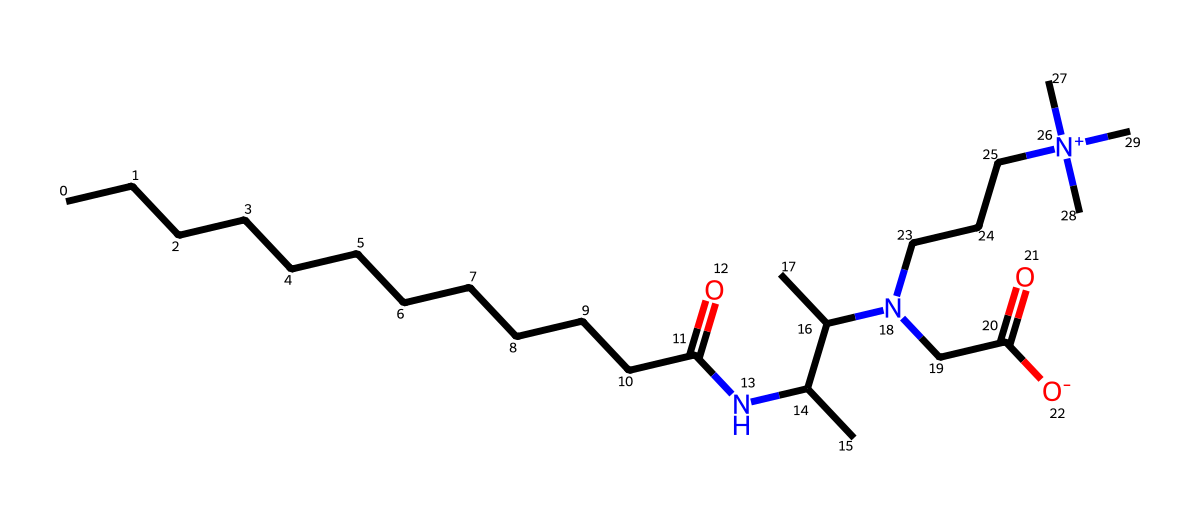What is the molecular formula of cocamidopropyl betaine? By analyzing the molecular structure indicated by the SMILES, we can count the number of carbon (C), hydrogen (H), nitrogen (N), and oxygen (O) atoms present. The chemical has several carbon chains which we can recognize from the structure. Compiling these counts gives us a molecular formula of C18H38N2O2.
Answer: C18H38N2O2 How many nitrogen atoms are in cocamidopropyl betaine? From the SMILES structure, we can see that there are two distinct nitrogen atoms (N) present in the entire structure. This can be concluded by identifying the 'N' occurrences in the SMILES representation.
Answer: 2 Does cocamidopropyl betaine possess a positive or negative charge? The presence of '[N+]' suggests that there is a positively charged nitrogen atom in the structure, indicating that this organic compound carries a positive charge at this nitrogen location.
Answer: positive What type of surfactant is cocamidopropyl betaine? Cocamidopropyl betaine is classified as an amphoteric surfactant, meaning it can act as both a positive and negative charged surfactant depending on the pH of the solution. This is deduced from the structure containing both quaternary nitrogen (positive) and carboxylate (negative) groups.
Answer: amphoteric How many carbon atoms are in the longest hydrocarbon chain of cocamidopropyl betaine? Examining the structure, we find a primary long hydrocarbon chain composed of 12 carbon atoms due to the lengthy aliphatic chain representation in SMILES, preceding functional groups such as nitrogen and oxygen.
Answer: 12 